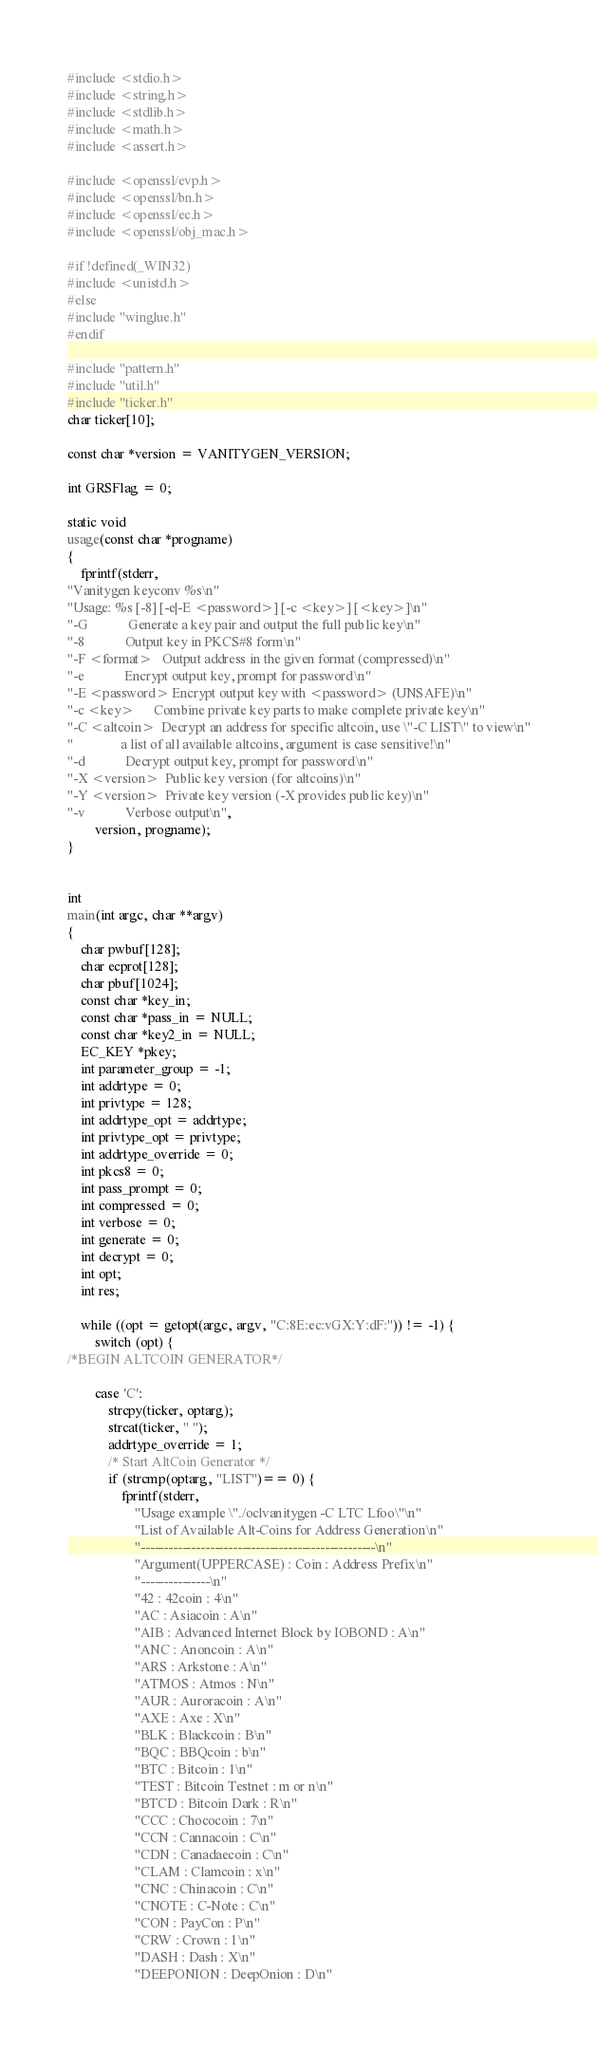<code> <loc_0><loc_0><loc_500><loc_500><_C_>#include <stdio.h>
#include <string.h>
#include <stdlib.h>
#include <math.h>
#include <assert.h>

#include <openssl/evp.h>
#include <openssl/bn.h>
#include <openssl/ec.h>
#include <openssl/obj_mac.h>

#if !defined(_WIN32)
#include <unistd.h>
#else
#include "winglue.h"
#endif

#include "pattern.h"
#include "util.h"
#include "ticker.h"
char ticker[10];

const char *version = VANITYGEN_VERSION;

int GRSFlag = 0;

static void
usage(const char *progname)
{
	fprintf(stderr,
"Vanitygen keyconv %s\n"
"Usage: %s [-8] [-e|-E <password>] [-c <key>] [<key>]\n"
"-G            Generate a key pair and output the full public key\n"
"-8            Output key in PKCS#8 form\n"
"-F <format>   Output address in the given format (compressed)\n"
"-e            Encrypt output key, prompt for password\n"
"-E <password> Encrypt output key with <password> (UNSAFE)\n"
"-c <key>      Combine private key parts to make complete private key\n"
"-C <altcoin>  Decrypt an address for specific altcoin, use \"-C LIST\" to view\n"
"              a list of all available altcoins, argument is case sensitive!\n"
"-d            Decrypt output key, prompt for password\n"
"-X <version>  Public key version (for altcoins)\n"
"-Y <version>  Private key version (-X provides public key)\n"
"-v            Verbose output\n",
		version, progname);
}


int
main(int argc, char **argv)
{
	char pwbuf[128];
	char ecprot[128];
	char pbuf[1024];
	const char *key_in;
	const char *pass_in = NULL;
	const char *key2_in = NULL;
	EC_KEY *pkey;
	int parameter_group = -1;
	int addrtype = 0;
	int privtype = 128;
	int addrtype_opt = addrtype;
	int privtype_opt = privtype;
	int addrtype_override = 0;
	int pkcs8 = 0;
	int pass_prompt = 0;
	int compressed = 0;
	int verbose = 0;
	int generate = 0;
	int decrypt = 0;
	int opt;
	int res;

	while ((opt = getopt(argc, argv, "C:8E:ec:vGX:Y:dF:")) != -1) {
		switch (opt) {
/*BEGIN ALTCOIN GENERATOR*/

		case 'C':
			strcpy(ticker, optarg);
			strcat(ticker, " ");
			addrtype_override = 1;
			/* Start AltCoin Generator */
			if (strcmp(optarg, "LIST")== 0) {
				fprintf(stderr,
					"Usage example \"./oclvanitygen -C LTC Lfoo\"\n"
					"List of Available Alt-Coins for Address Generation\n"
					"---------------------------------------------------\n"
					"Argument(UPPERCASE) : Coin : Address Prefix\n"
					"---------------\n"
					"42 : 42coin : 4\n"
					"AC : Asiacoin : A\n"
					"AIB : Advanced Internet Block by IOBOND : A\n"
					"ANC : Anoncoin : A\n"
					"ARS : Arkstone : A\n"
					"ATMOS : Atmos : N\n"
					"AUR : Auroracoin : A\n"
					"AXE : Axe : X\n"
					"BLK : Blackcoin : B\n"
					"BQC : BBQcoin : b\n"
					"BTC : Bitcoin : 1\n"
					"TEST : Bitcoin Testnet : m or n\n"
					"BTCD : Bitcoin Dark : R\n"
					"CCC : Chococoin : 7\n"
					"CCN : Cannacoin : C\n"
					"CDN : Canadaecoin : C\n"
					"CLAM : Clamcoin : x\n"
					"CNC : Chinacoin : C\n"
					"CNOTE : C-Note : C\n"
					"CON : PayCon : P\n"
					"CRW : Crown : 1\n"
					"DASH : Dash : X\n"
					"DEEPONION : DeepOnion : D\n"</code> 